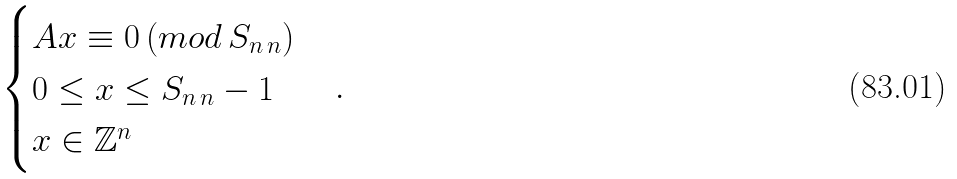<formula> <loc_0><loc_0><loc_500><loc_500>\begin{cases} A x \equiv 0 \, ( m o d \, S _ { n \, n } ) \\ 0 \leq x \leq S _ { n \, n } - 1 \\ x \in \mathbb { Z } ^ { n } \\ \end{cases} .</formula> 